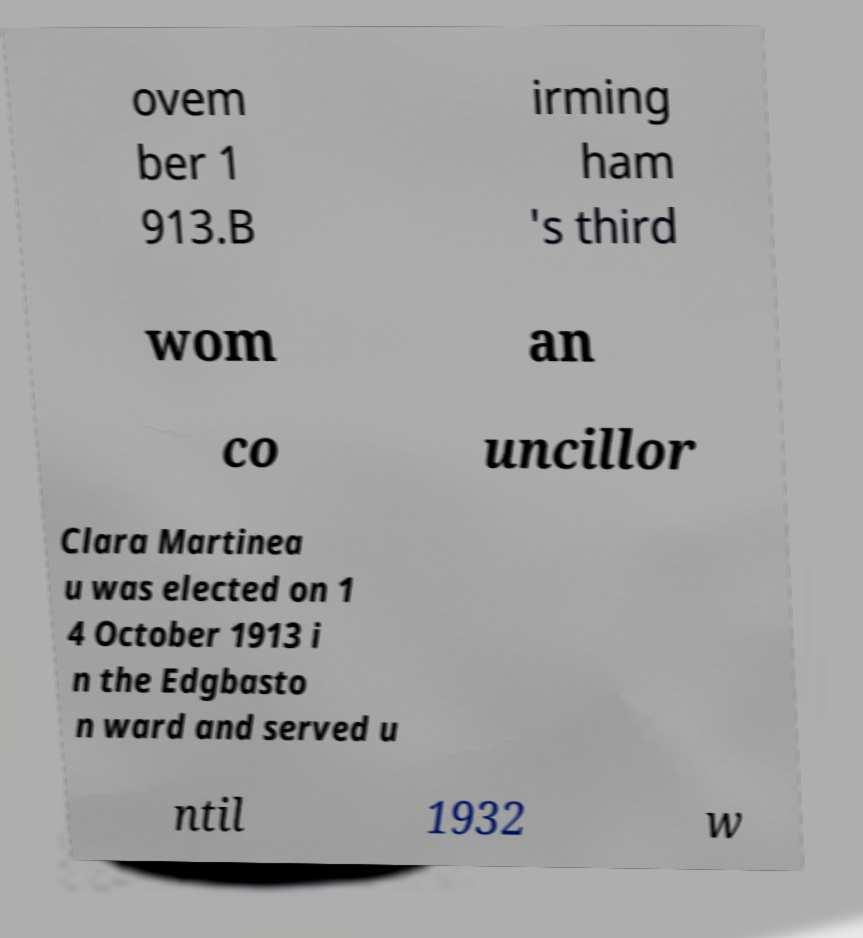There's text embedded in this image that I need extracted. Can you transcribe it verbatim? ovem ber 1 913.B irming ham 's third wom an co uncillor Clara Martinea u was elected on 1 4 October 1913 i n the Edgbasto n ward and served u ntil 1932 w 